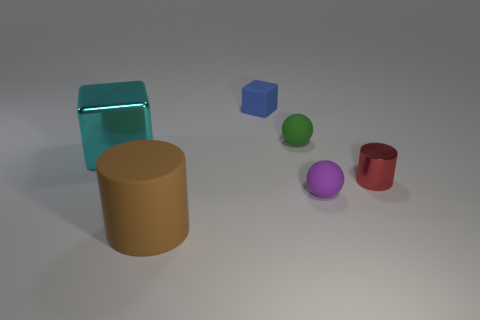What materials do the objects in the image seem to be made of? The objects in the image appear to be made of different materials. The large cylinder on the left looks to be made of a matte, slightly textured material, perhaps resembling cardboard. The transparent blue object is likely a rubber material, given its sheen and translucency. The small cube appears solid and colored uniformly, suggesting it might be made of plastic. The small spheres seem to have a matte surface, likely indicative of a painted or coated surface, while the small red cylinder's reflective surface suggests a metallic composition. 